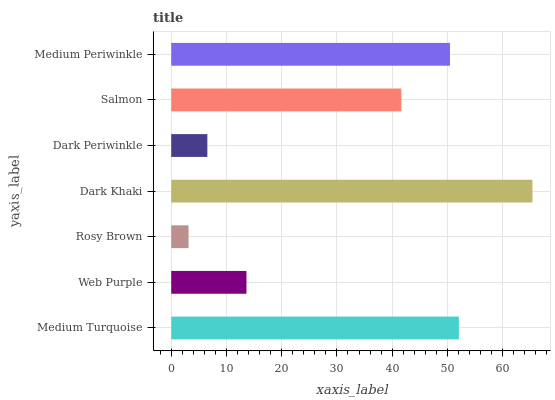Is Rosy Brown the minimum?
Answer yes or no. Yes. Is Dark Khaki the maximum?
Answer yes or no. Yes. Is Web Purple the minimum?
Answer yes or no. No. Is Web Purple the maximum?
Answer yes or no. No. Is Medium Turquoise greater than Web Purple?
Answer yes or no. Yes. Is Web Purple less than Medium Turquoise?
Answer yes or no. Yes. Is Web Purple greater than Medium Turquoise?
Answer yes or no. No. Is Medium Turquoise less than Web Purple?
Answer yes or no. No. Is Salmon the high median?
Answer yes or no. Yes. Is Salmon the low median?
Answer yes or no. Yes. Is Dark Periwinkle the high median?
Answer yes or no. No. Is Medium Turquoise the low median?
Answer yes or no. No. 